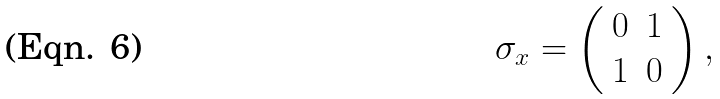<formula> <loc_0><loc_0><loc_500><loc_500>\sigma _ { x } = \left ( \begin{array} { c l c r } 0 & 1 \\ 1 & 0 \end{array} \right ) ,</formula> 